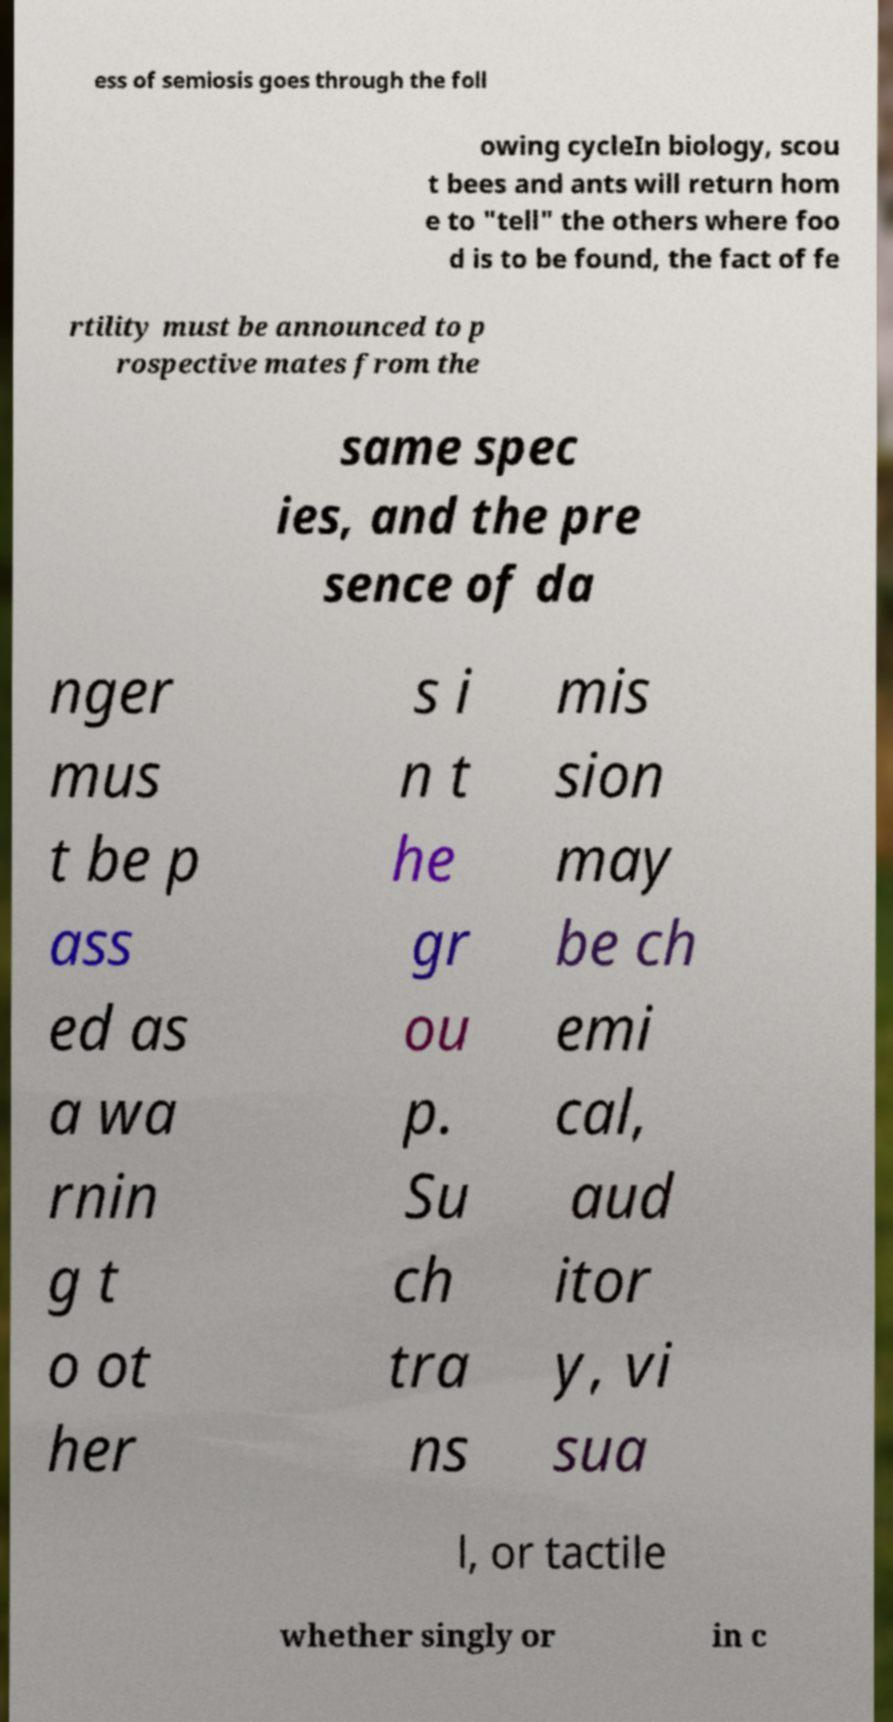Please identify and transcribe the text found in this image. ess of semiosis goes through the foll owing cycleIn biology, scou t bees and ants will return hom e to "tell" the others where foo d is to be found, the fact of fe rtility must be announced to p rospective mates from the same spec ies, and the pre sence of da nger mus t be p ass ed as a wa rnin g t o ot her s i n t he gr ou p. Su ch tra ns mis sion may be ch emi cal, aud itor y, vi sua l, or tactile whether singly or in c 